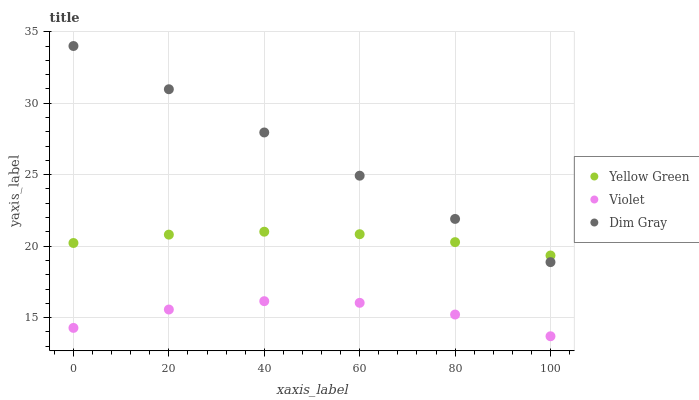Does Violet have the minimum area under the curve?
Answer yes or no. Yes. Does Dim Gray have the maximum area under the curve?
Answer yes or no. Yes. Does Yellow Green have the minimum area under the curve?
Answer yes or no. No. Does Yellow Green have the maximum area under the curve?
Answer yes or no. No. Is Dim Gray the smoothest?
Answer yes or no. Yes. Is Violet the roughest?
Answer yes or no. Yes. Is Yellow Green the smoothest?
Answer yes or no. No. Is Yellow Green the roughest?
Answer yes or no. No. Does Violet have the lowest value?
Answer yes or no. Yes. Does Yellow Green have the lowest value?
Answer yes or no. No. Does Dim Gray have the highest value?
Answer yes or no. Yes. Does Yellow Green have the highest value?
Answer yes or no. No. Is Violet less than Yellow Green?
Answer yes or no. Yes. Is Dim Gray greater than Violet?
Answer yes or no. Yes. Does Dim Gray intersect Yellow Green?
Answer yes or no. Yes. Is Dim Gray less than Yellow Green?
Answer yes or no. No. Is Dim Gray greater than Yellow Green?
Answer yes or no. No. Does Violet intersect Yellow Green?
Answer yes or no. No. 